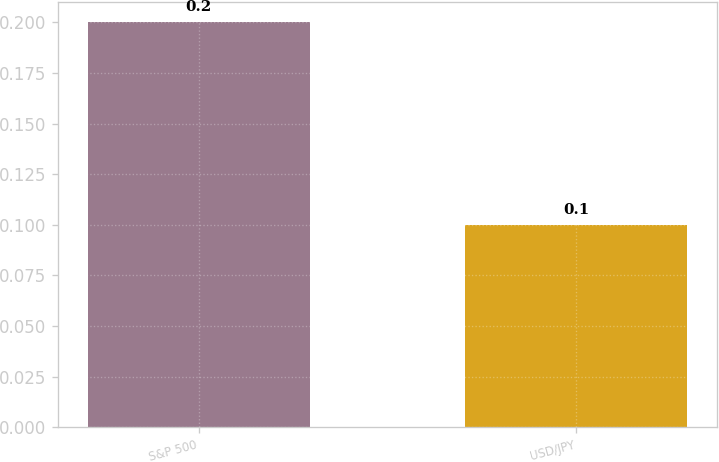Convert chart. <chart><loc_0><loc_0><loc_500><loc_500><bar_chart><fcel>S&P 500<fcel>USD/JPY<nl><fcel>0.2<fcel>0.1<nl></chart> 